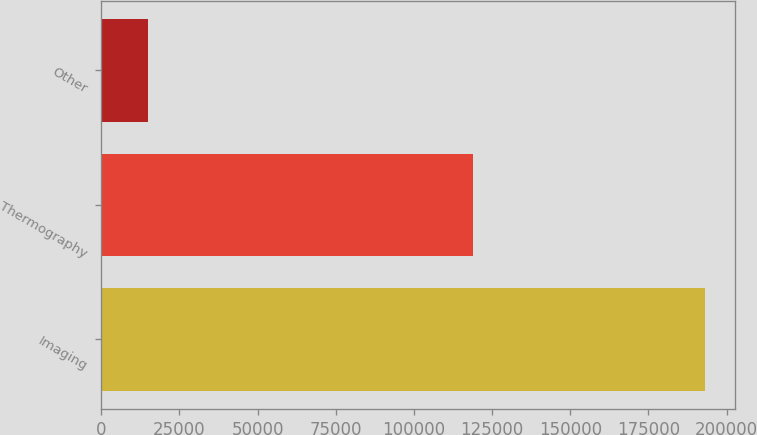Convert chart. <chart><loc_0><loc_0><loc_500><loc_500><bar_chart><fcel>Imaging<fcel>Thermography<fcel>Other<nl><fcel>193132<fcel>118847<fcel>14886<nl></chart> 